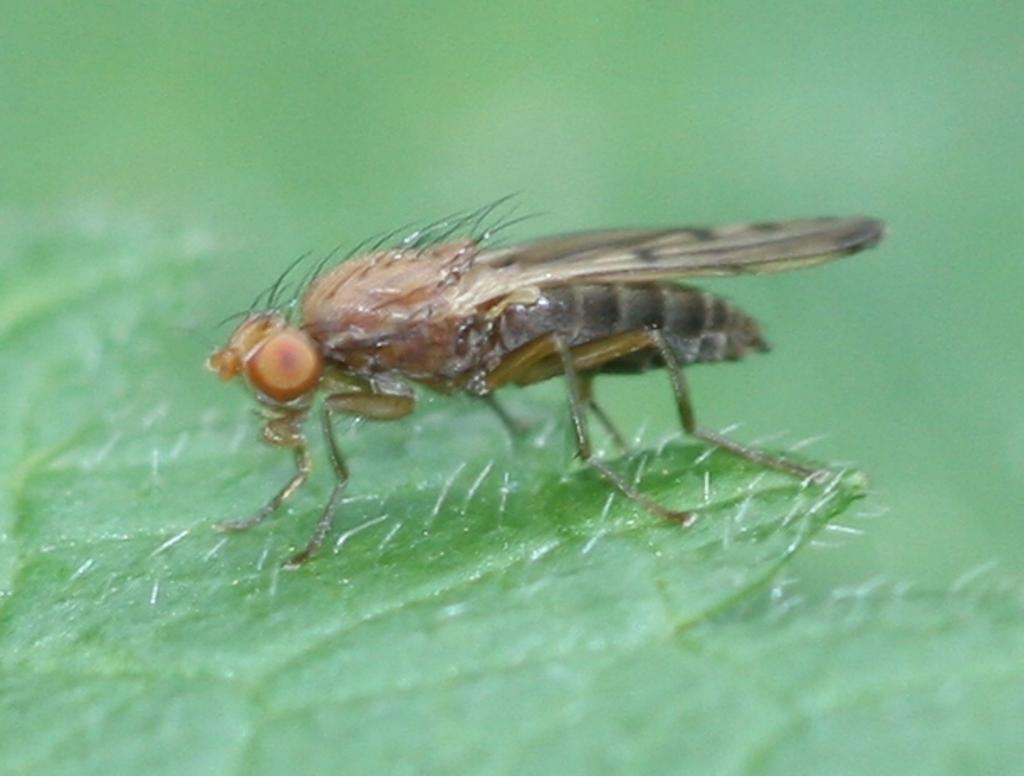What type of creature can be seen in the image? There is an insect in the image. Can you describe the color of the insect? The insect is brown and black in color. What is the insect resting on in the image? The insect is on a green object. What is the dominant color in the background of the image? The background of the image is entirely green. What type of event is taking place in the image involving bells? There is no event or bells present in the image; it features an insect on a green object with a green background. 